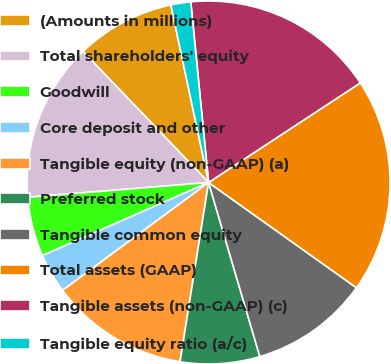<chart> <loc_0><loc_0><loc_500><loc_500><pie_chart><fcel>(Amounts in millions)<fcel>Total shareholders' equity<fcel>Goodwill<fcel>Core deposit and other<fcel>Tangible equity (non-GAAP) (a)<fcel>Preferred stock<fcel>Tangible common equity<fcel>Total assets (GAAP)<fcel>Tangible assets (non-GAAP) (c)<fcel>Tangible equity ratio (a/c)<nl><fcel>8.83%<fcel>14.13%<fcel>5.3%<fcel>3.53%<fcel>12.36%<fcel>7.07%<fcel>10.6%<fcel>19.09%<fcel>17.32%<fcel>1.77%<nl></chart> 